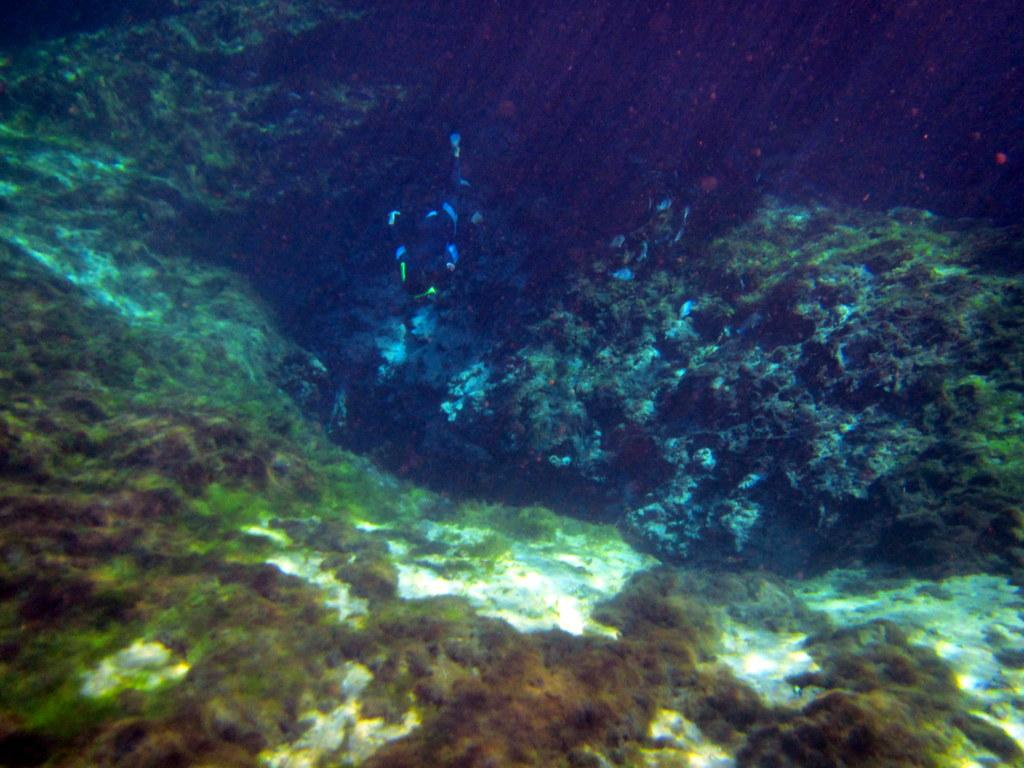What is the main feature of the image? There is a large water body in the image. What can be seen in the water? There is a creature swimming in the water. Are there any plants visible in the image? Yes, plants are present in the water. What type of wine is being served at the beach party in the image? There is no beach party or wine present in the image; it features a large water body with a creature swimming and plants. 